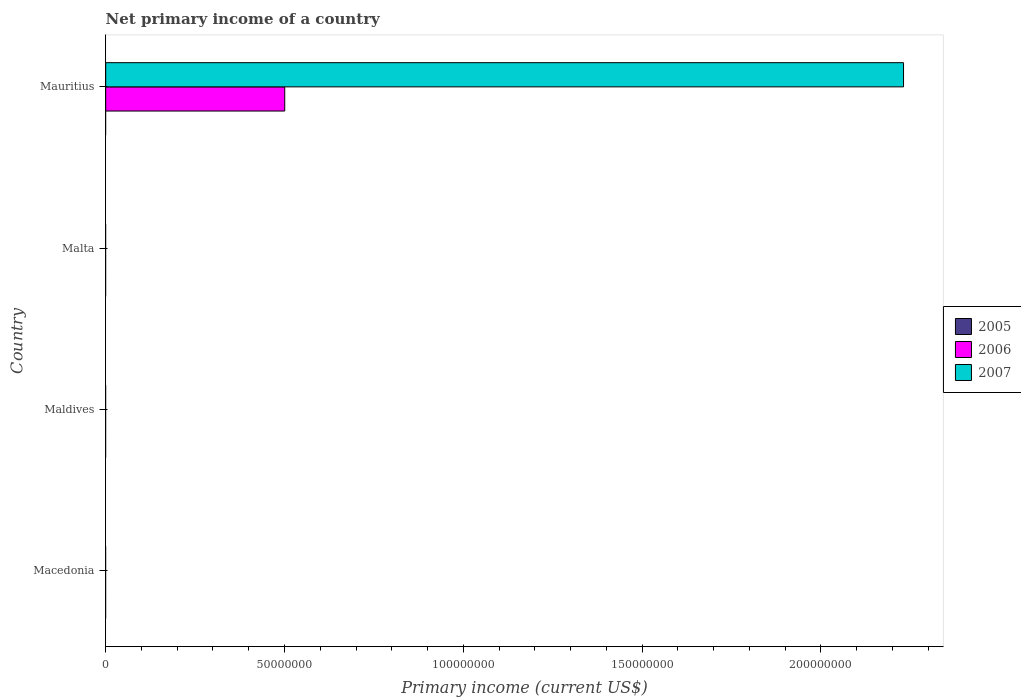Are the number of bars on each tick of the Y-axis equal?
Offer a terse response. No. What is the label of the 1st group of bars from the top?
Your answer should be very brief. Mauritius. In how many cases, is the number of bars for a given country not equal to the number of legend labels?
Keep it short and to the point. 4. What is the primary income in 2007 in Maldives?
Give a very brief answer. 0. Across all countries, what is the maximum primary income in 2006?
Provide a succinct answer. 5.01e+07. In which country was the primary income in 2006 maximum?
Keep it short and to the point. Mauritius. What is the total primary income in 2006 in the graph?
Ensure brevity in your answer.  5.01e+07. What is the difference between the primary income in 2007 in Malta and the primary income in 2006 in Maldives?
Offer a terse response. 0. What is the average primary income in 2006 per country?
Keep it short and to the point. 1.25e+07. What is the difference between the primary income in 2007 and primary income in 2006 in Mauritius?
Give a very brief answer. 1.73e+08. In how many countries, is the primary income in 2005 greater than 40000000 US$?
Provide a succinct answer. 0. What is the difference between the highest and the lowest primary income in 2006?
Give a very brief answer. 5.01e+07. Is it the case that in every country, the sum of the primary income in 2007 and primary income in 2006 is greater than the primary income in 2005?
Offer a very short reply. No. How many bars are there?
Keep it short and to the point. 2. How many countries are there in the graph?
Your response must be concise. 4. Are the values on the major ticks of X-axis written in scientific E-notation?
Offer a terse response. No. Does the graph contain any zero values?
Ensure brevity in your answer.  Yes. Does the graph contain grids?
Make the answer very short. No. What is the title of the graph?
Keep it short and to the point. Net primary income of a country. What is the label or title of the X-axis?
Offer a very short reply. Primary income (current US$). What is the Primary income (current US$) in 2005 in Maldives?
Offer a terse response. 0. What is the Primary income (current US$) in 2005 in Malta?
Offer a terse response. 0. What is the Primary income (current US$) of 2006 in Malta?
Make the answer very short. 0. What is the Primary income (current US$) in 2007 in Malta?
Ensure brevity in your answer.  0. What is the Primary income (current US$) in 2005 in Mauritius?
Ensure brevity in your answer.  0. What is the Primary income (current US$) of 2006 in Mauritius?
Ensure brevity in your answer.  5.01e+07. What is the Primary income (current US$) of 2007 in Mauritius?
Give a very brief answer. 2.23e+08. Across all countries, what is the maximum Primary income (current US$) in 2006?
Your response must be concise. 5.01e+07. Across all countries, what is the maximum Primary income (current US$) in 2007?
Make the answer very short. 2.23e+08. Across all countries, what is the minimum Primary income (current US$) of 2006?
Give a very brief answer. 0. Across all countries, what is the minimum Primary income (current US$) in 2007?
Ensure brevity in your answer.  0. What is the total Primary income (current US$) in 2006 in the graph?
Make the answer very short. 5.01e+07. What is the total Primary income (current US$) of 2007 in the graph?
Give a very brief answer. 2.23e+08. What is the average Primary income (current US$) in 2006 per country?
Your answer should be compact. 1.25e+07. What is the average Primary income (current US$) in 2007 per country?
Your answer should be compact. 5.58e+07. What is the difference between the Primary income (current US$) of 2006 and Primary income (current US$) of 2007 in Mauritius?
Give a very brief answer. -1.73e+08. What is the difference between the highest and the lowest Primary income (current US$) in 2006?
Your response must be concise. 5.01e+07. What is the difference between the highest and the lowest Primary income (current US$) in 2007?
Offer a terse response. 2.23e+08. 